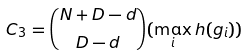<formula> <loc_0><loc_0><loc_500><loc_500>C _ { 3 } = \binom { N + D - d } { D - d } ( \max _ { i } h ( g _ { i } ) )</formula> 